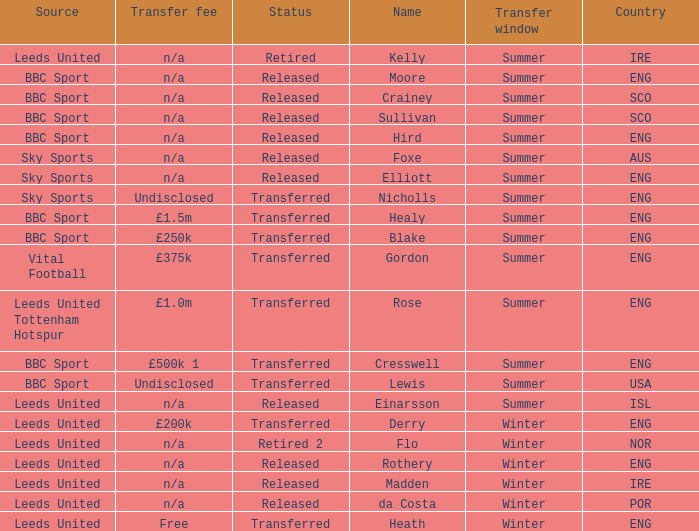What is the current status of the person named Nicholls? Transferred. 